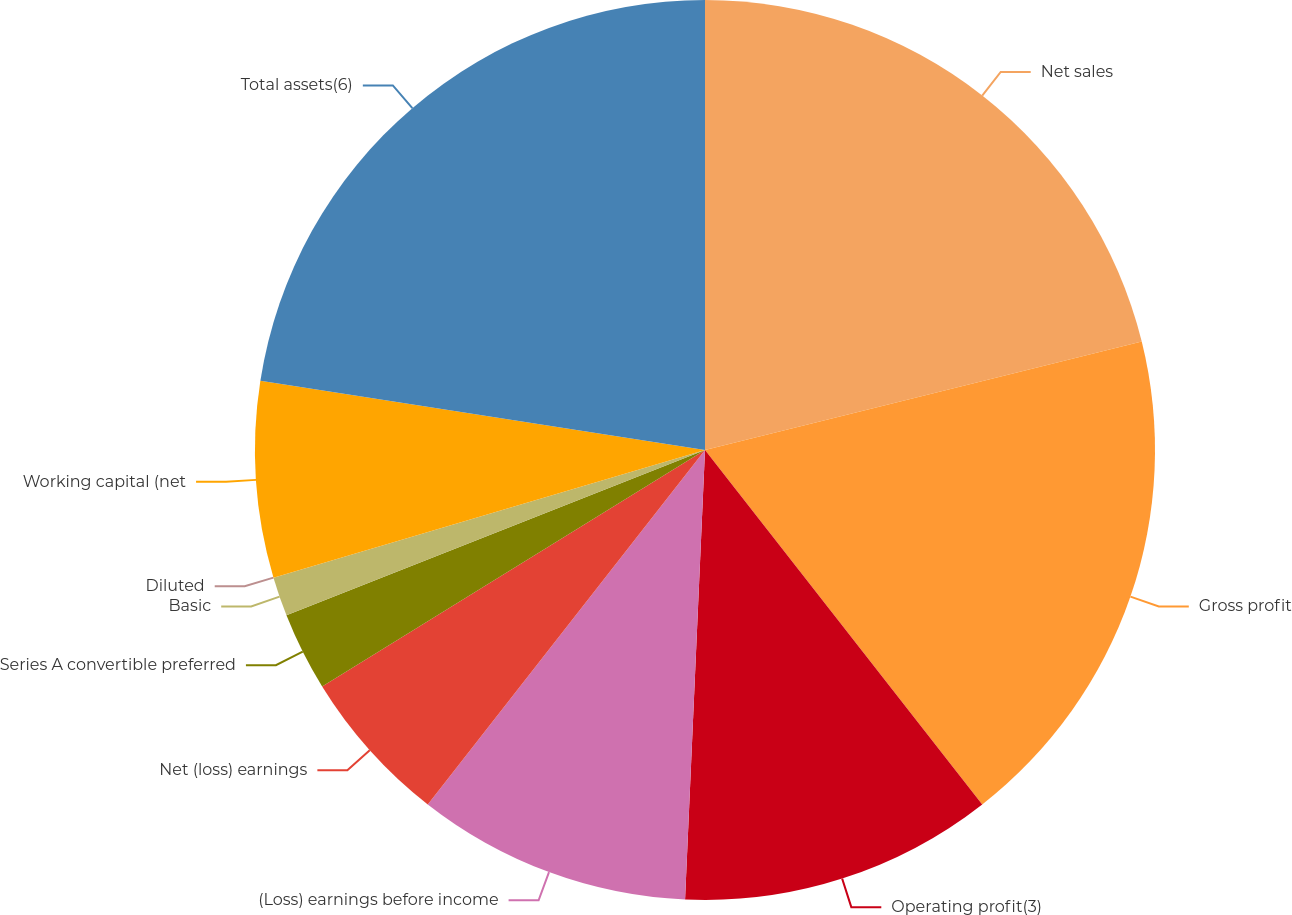Convert chart. <chart><loc_0><loc_0><loc_500><loc_500><pie_chart><fcel>Net sales<fcel>Gross profit<fcel>Operating profit(3)<fcel>(Loss) earnings before income<fcel>Net (loss) earnings<fcel>Series A convertible preferred<fcel>Basic<fcel>Diluted<fcel>Working capital (net<fcel>Total assets(6)<nl><fcel>21.13%<fcel>18.31%<fcel>11.27%<fcel>9.86%<fcel>5.63%<fcel>2.82%<fcel>1.41%<fcel>0.0%<fcel>7.04%<fcel>22.54%<nl></chart> 